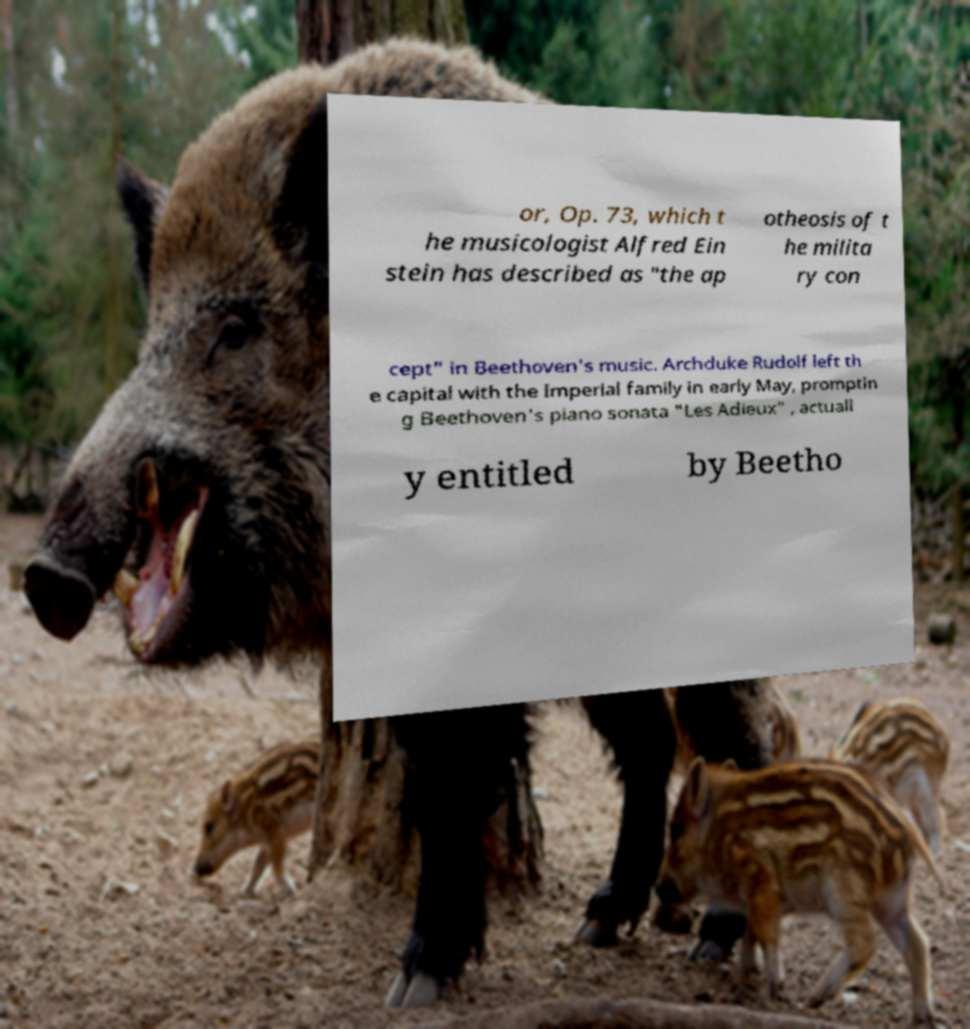For documentation purposes, I need the text within this image transcribed. Could you provide that? or, Op. 73, which t he musicologist Alfred Ein stein has described as "the ap otheosis of t he milita ry con cept" in Beethoven's music. Archduke Rudolf left th e capital with the Imperial family in early May, promptin g Beethoven's piano sonata "Les Adieux" , actuall y entitled by Beetho 